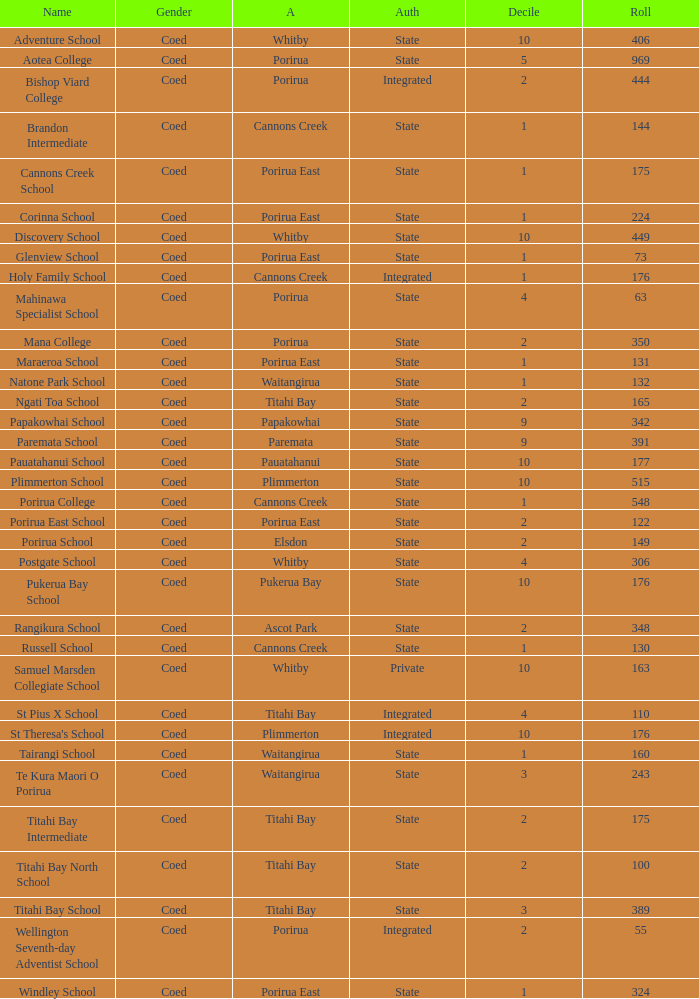What is the roll of Bishop Viard College (An Integrated College), which has a decile larger than 1? 1.0. 